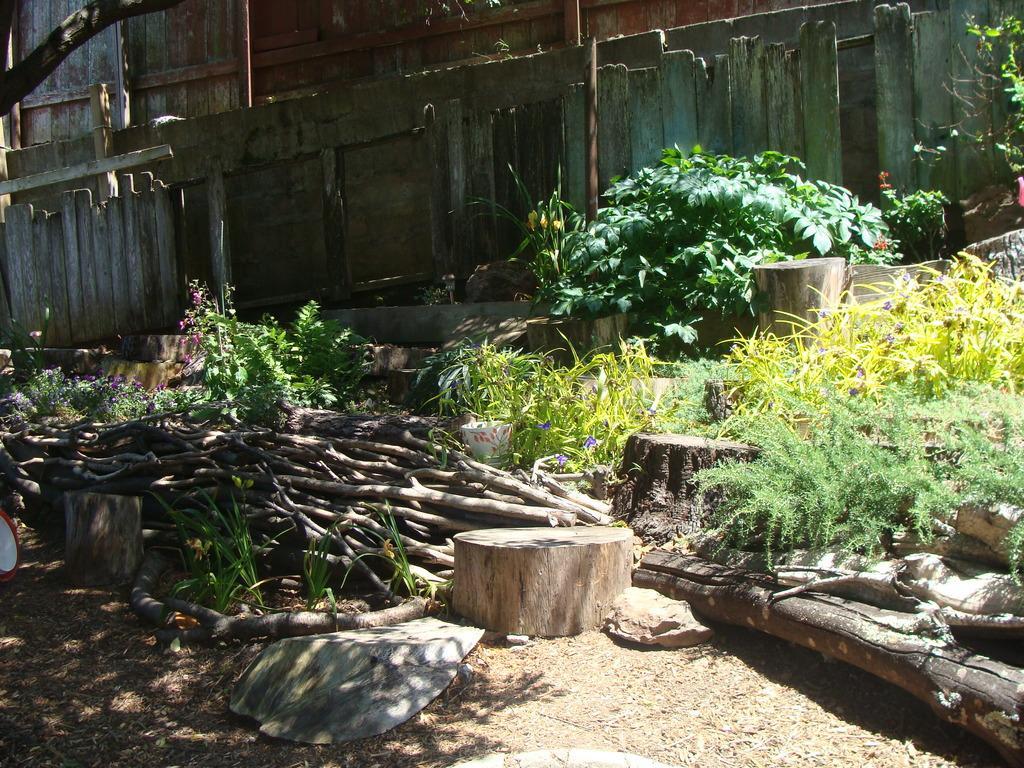Please provide a concise description of this image. At the bottom of the picture, we see dry grass and the wooden blocks. On the right side, we see the plants and the shrubs. In the middle, we see the wooden sticks and on the left side, we see the plants which have flowers and these flowers are in violet and pink color. In the background, we see the plants, poles and the wooden railing. We see a building in the background. 